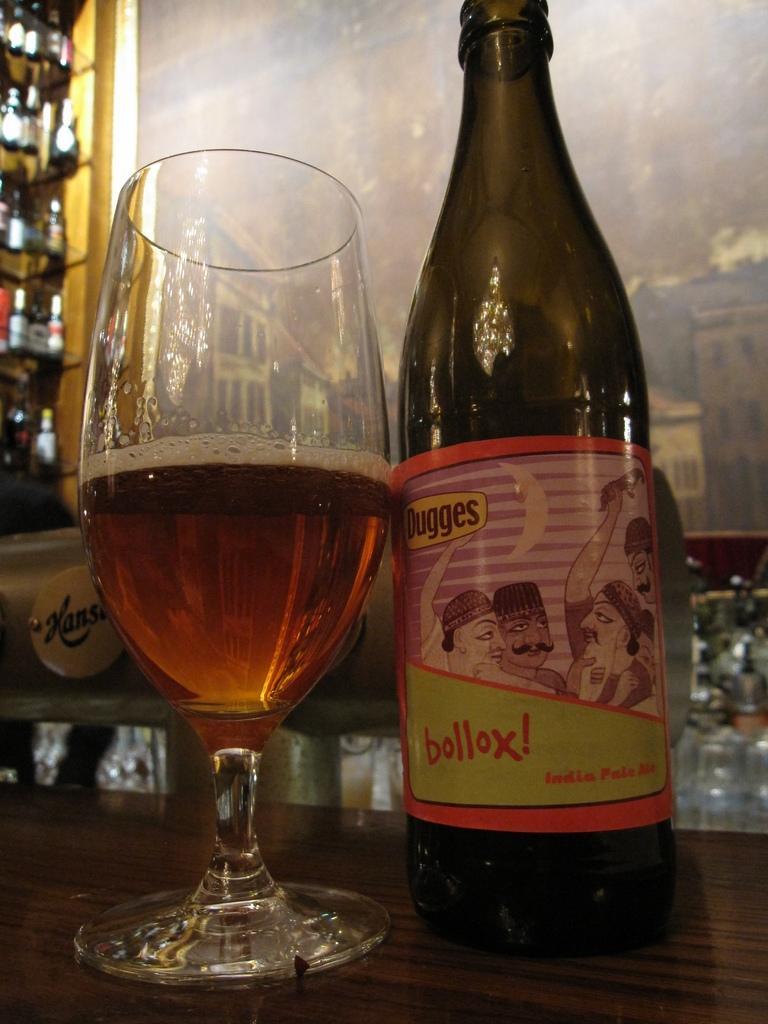Can you describe this image briefly? In this Image I see a glass and a bottle and In the background I see lot of bottles. 